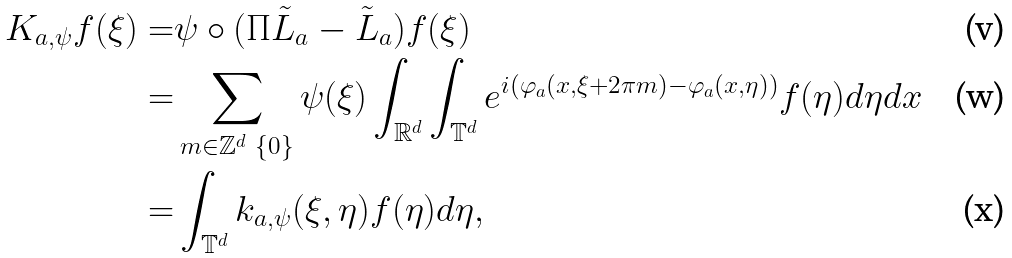Convert formula to latex. <formula><loc_0><loc_0><loc_500><loc_500>K _ { a , \psi } f ( \xi ) = & \psi \circ ( \Pi \tilde { L } _ { a } - \tilde { L } _ { a } ) f ( \xi ) \\ = & \sum _ { m \in \mathbb { Z } ^ { d } \ \{ 0 \} } \psi ( \xi ) \int _ { \mathbb { R } ^ { d } } \int _ { \mathbb { T } ^ { d } } e ^ { i ( \varphi _ { a } ( x , \xi + 2 \pi m ) - \varphi _ { a } ( x , \eta ) ) } f ( \eta ) d \eta d x \\ = & \int _ { \mathbb { T } ^ { d } } k _ { a , \psi } ( \xi , \eta ) f ( \eta ) d \eta ,</formula> 